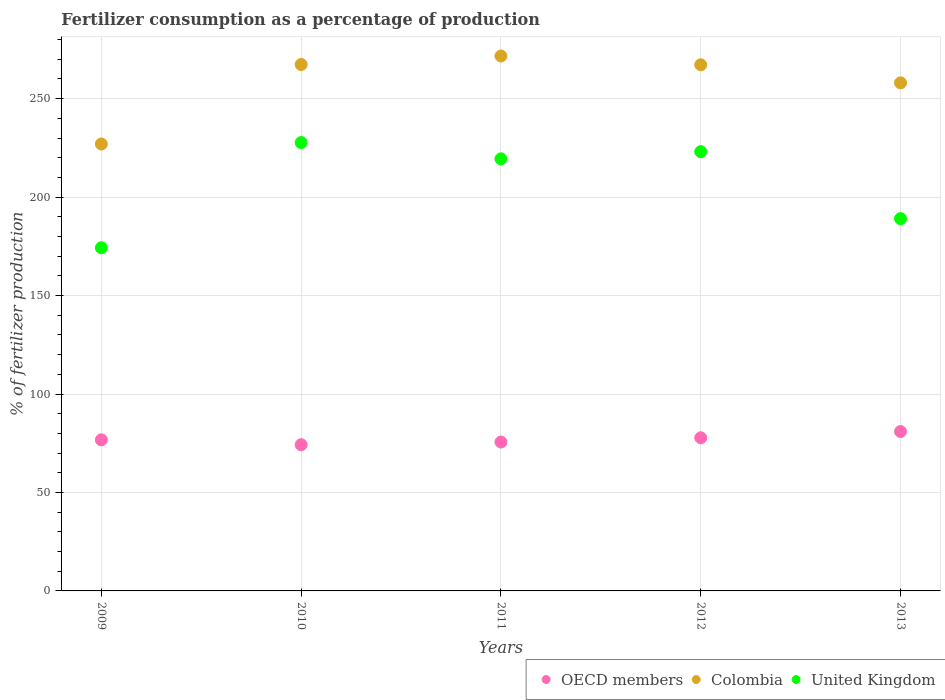How many different coloured dotlines are there?
Ensure brevity in your answer.  3. Is the number of dotlines equal to the number of legend labels?
Give a very brief answer. Yes. What is the percentage of fertilizers consumed in United Kingdom in 2011?
Your answer should be compact. 219.43. Across all years, what is the maximum percentage of fertilizers consumed in United Kingdom?
Your answer should be very brief. 227.69. Across all years, what is the minimum percentage of fertilizers consumed in United Kingdom?
Give a very brief answer. 174.26. In which year was the percentage of fertilizers consumed in United Kingdom maximum?
Provide a short and direct response. 2010. In which year was the percentage of fertilizers consumed in United Kingdom minimum?
Ensure brevity in your answer.  2009. What is the total percentage of fertilizers consumed in OECD members in the graph?
Provide a succinct answer. 385.32. What is the difference between the percentage of fertilizers consumed in OECD members in 2011 and that in 2013?
Keep it short and to the point. -5.33. What is the difference between the percentage of fertilizers consumed in Colombia in 2009 and the percentage of fertilizers consumed in OECD members in 2012?
Provide a succinct answer. 149.19. What is the average percentage of fertilizers consumed in United Kingdom per year?
Provide a succinct answer. 206.7. In the year 2011, what is the difference between the percentage of fertilizers consumed in United Kingdom and percentage of fertilizers consumed in Colombia?
Offer a very short reply. -52.23. In how many years, is the percentage of fertilizers consumed in OECD members greater than 250 %?
Make the answer very short. 0. What is the ratio of the percentage of fertilizers consumed in Colombia in 2010 to that in 2011?
Your answer should be very brief. 0.98. Is the percentage of fertilizers consumed in Colombia in 2010 less than that in 2013?
Provide a short and direct response. No. Is the difference between the percentage of fertilizers consumed in United Kingdom in 2009 and 2012 greater than the difference between the percentage of fertilizers consumed in Colombia in 2009 and 2012?
Your answer should be very brief. No. What is the difference between the highest and the second highest percentage of fertilizers consumed in United Kingdom?
Your answer should be compact. 4.62. What is the difference between the highest and the lowest percentage of fertilizers consumed in United Kingdom?
Your answer should be compact. 53.43. In how many years, is the percentage of fertilizers consumed in Colombia greater than the average percentage of fertilizers consumed in Colombia taken over all years?
Provide a succinct answer. 3. Is it the case that in every year, the sum of the percentage of fertilizers consumed in United Kingdom and percentage of fertilizers consumed in Colombia  is greater than the percentage of fertilizers consumed in OECD members?
Give a very brief answer. Yes. Is the percentage of fertilizers consumed in United Kingdom strictly greater than the percentage of fertilizers consumed in OECD members over the years?
Ensure brevity in your answer.  Yes. Is the percentage of fertilizers consumed in OECD members strictly less than the percentage of fertilizers consumed in Colombia over the years?
Make the answer very short. Yes. How many dotlines are there?
Make the answer very short. 3. How many years are there in the graph?
Give a very brief answer. 5. What is the difference between two consecutive major ticks on the Y-axis?
Give a very brief answer. 50. Does the graph contain grids?
Keep it short and to the point. Yes. Where does the legend appear in the graph?
Give a very brief answer. Bottom right. How many legend labels are there?
Provide a succinct answer. 3. How are the legend labels stacked?
Offer a very short reply. Horizontal. What is the title of the graph?
Offer a very short reply. Fertilizer consumption as a percentage of production. What is the label or title of the X-axis?
Give a very brief answer. Years. What is the label or title of the Y-axis?
Your answer should be compact. % of fertilizer production. What is the % of fertilizer production in OECD members in 2009?
Your answer should be compact. 76.72. What is the % of fertilizer production in Colombia in 2009?
Offer a terse response. 226.96. What is the % of fertilizer production in United Kingdom in 2009?
Offer a terse response. 174.26. What is the % of fertilizer production of OECD members in 2010?
Your response must be concise. 74.26. What is the % of fertilizer production of Colombia in 2010?
Your answer should be compact. 267.34. What is the % of fertilizer production of United Kingdom in 2010?
Make the answer very short. 227.69. What is the % of fertilizer production in OECD members in 2011?
Make the answer very short. 75.62. What is the % of fertilizer production in Colombia in 2011?
Offer a very short reply. 271.65. What is the % of fertilizer production of United Kingdom in 2011?
Keep it short and to the point. 219.43. What is the % of fertilizer production of OECD members in 2012?
Make the answer very short. 77.78. What is the % of fertilizer production in Colombia in 2012?
Keep it short and to the point. 267.2. What is the % of fertilizer production in United Kingdom in 2012?
Give a very brief answer. 223.08. What is the % of fertilizer production in OECD members in 2013?
Offer a terse response. 80.95. What is the % of fertilizer production of Colombia in 2013?
Offer a terse response. 258.03. What is the % of fertilizer production of United Kingdom in 2013?
Offer a very short reply. 189.06. Across all years, what is the maximum % of fertilizer production in OECD members?
Make the answer very short. 80.95. Across all years, what is the maximum % of fertilizer production in Colombia?
Give a very brief answer. 271.65. Across all years, what is the maximum % of fertilizer production of United Kingdom?
Your answer should be compact. 227.69. Across all years, what is the minimum % of fertilizer production in OECD members?
Provide a succinct answer. 74.26. Across all years, what is the minimum % of fertilizer production of Colombia?
Offer a very short reply. 226.96. Across all years, what is the minimum % of fertilizer production of United Kingdom?
Your answer should be compact. 174.26. What is the total % of fertilizer production in OECD members in the graph?
Your response must be concise. 385.32. What is the total % of fertilizer production in Colombia in the graph?
Provide a succinct answer. 1291.18. What is the total % of fertilizer production of United Kingdom in the graph?
Offer a terse response. 1033.51. What is the difference between the % of fertilizer production in OECD members in 2009 and that in 2010?
Offer a terse response. 2.45. What is the difference between the % of fertilizer production in Colombia in 2009 and that in 2010?
Give a very brief answer. -40.38. What is the difference between the % of fertilizer production of United Kingdom in 2009 and that in 2010?
Keep it short and to the point. -53.43. What is the difference between the % of fertilizer production of OECD members in 2009 and that in 2011?
Provide a succinct answer. 1.1. What is the difference between the % of fertilizer production of Colombia in 2009 and that in 2011?
Offer a very short reply. -44.69. What is the difference between the % of fertilizer production in United Kingdom in 2009 and that in 2011?
Provide a short and direct response. -45.16. What is the difference between the % of fertilizer production in OECD members in 2009 and that in 2012?
Offer a very short reply. -1.06. What is the difference between the % of fertilizer production of Colombia in 2009 and that in 2012?
Give a very brief answer. -40.24. What is the difference between the % of fertilizer production in United Kingdom in 2009 and that in 2012?
Make the answer very short. -48.81. What is the difference between the % of fertilizer production of OECD members in 2009 and that in 2013?
Your answer should be compact. -4.23. What is the difference between the % of fertilizer production of Colombia in 2009 and that in 2013?
Give a very brief answer. -31.06. What is the difference between the % of fertilizer production in United Kingdom in 2009 and that in 2013?
Your answer should be very brief. -14.79. What is the difference between the % of fertilizer production in OECD members in 2010 and that in 2011?
Your answer should be very brief. -1.35. What is the difference between the % of fertilizer production of Colombia in 2010 and that in 2011?
Provide a succinct answer. -4.31. What is the difference between the % of fertilizer production of United Kingdom in 2010 and that in 2011?
Provide a short and direct response. 8.27. What is the difference between the % of fertilizer production in OECD members in 2010 and that in 2012?
Ensure brevity in your answer.  -3.51. What is the difference between the % of fertilizer production in Colombia in 2010 and that in 2012?
Keep it short and to the point. 0.15. What is the difference between the % of fertilizer production in United Kingdom in 2010 and that in 2012?
Your response must be concise. 4.62. What is the difference between the % of fertilizer production of OECD members in 2010 and that in 2013?
Provide a short and direct response. -6.68. What is the difference between the % of fertilizer production of Colombia in 2010 and that in 2013?
Your answer should be compact. 9.32. What is the difference between the % of fertilizer production of United Kingdom in 2010 and that in 2013?
Your answer should be very brief. 38.64. What is the difference between the % of fertilizer production in OECD members in 2011 and that in 2012?
Offer a terse response. -2.16. What is the difference between the % of fertilizer production of Colombia in 2011 and that in 2012?
Provide a succinct answer. 4.46. What is the difference between the % of fertilizer production of United Kingdom in 2011 and that in 2012?
Make the answer very short. -3.65. What is the difference between the % of fertilizer production in OECD members in 2011 and that in 2013?
Your answer should be compact. -5.33. What is the difference between the % of fertilizer production of Colombia in 2011 and that in 2013?
Your answer should be very brief. 13.63. What is the difference between the % of fertilizer production of United Kingdom in 2011 and that in 2013?
Make the answer very short. 30.37. What is the difference between the % of fertilizer production in OECD members in 2012 and that in 2013?
Your answer should be compact. -3.17. What is the difference between the % of fertilizer production of Colombia in 2012 and that in 2013?
Provide a succinct answer. 9.17. What is the difference between the % of fertilizer production in United Kingdom in 2012 and that in 2013?
Offer a terse response. 34.02. What is the difference between the % of fertilizer production in OECD members in 2009 and the % of fertilizer production in Colombia in 2010?
Your response must be concise. -190.63. What is the difference between the % of fertilizer production in OECD members in 2009 and the % of fertilizer production in United Kingdom in 2010?
Your response must be concise. -150.98. What is the difference between the % of fertilizer production in Colombia in 2009 and the % of fertilizer production in United Kingdom in 2010?
Your answer should be very brief. -0.73. What is the difference between the % of fertilizer production of OECD members in 2009 and the % of fertilizer production of Colombia in 2011?
Keep it short and to the point. -194.94. What is the difference between the % of fertilizer production in OECD members in 2009 and the % of fertilizer production in United Kingdom in 2011?
Your answer should be very brief. -142.71. What is the difference between the % of fertilizer production in Colombia in 2009 and the % of fertilizer production in United Kingdom in 2011?
Your response must be concise. 7.54. What is the difference between the % of fertilizer production of OECD members in 2009 and the % of fertilizer production of Colombia in 2012?
Keep it short and to the point. -190.48. What is the difference between the % of fertilizer production in OECD members in 2009 and the % of fertilizer production in United Kingdom in 2012?
Your answer should be compact. -146.36. What is the difference between the % of fertilizer production of Colombia in 2009 and the % of fertilizer production of United Kingdom in 2012?
Offer a very short reply. 3.89. What is the difference between the % of fertilizer production of OECD members in 2009 and the % of fertilizer production of Colombia in 2013?
Keep it short and to the point. -181.31. What is the difference between the % of fertilizer production of OECD members in 2009 and the % of fertilizer production of United Kingdom in 2013?
Your answer should be very brief. -112.34. What is the difference between the % of fertilizer production in Colombia in 2009 and the % of fertilizer production in United Kingdom in 2013?
Provide a succinct answer. 37.91. What is the difference between the % of fertilizer production of OECD members in 2010 and the % of fertilizer production of Colombia in 2011?
Give a very brief answer. -197.39. What is the difference between the % of fertilizer production in OECD members in 2010 and the % of fertilizer production in United Kingdom in 2011?
Offer a very short reply. -145.16. What is the difference between the % of fertilizer production in Colombia in 2010 and the % of fertilizer production in United Kingdom in 2011?
Provide a succinct answer. 47.92. What is the difference between the % of fertilizer production in OECD members in 2010 and the % of fertilizer production in Colombia in 2012?
Make the answer very short. -192.94. What is the difference between the % of fertilizer production of OECD members in 2010 and the % of fertilizer production of United Kingdom in 2012?
Keep it short and to the point. -148.81. What is the difference between the % of fertilizer production of Colombia in 2010 and the % of fertilizer production of United Kingdom in 2012?
Provide a succinct answer. 44.27. What is the difference between the % of fertilizer production of OECD members in 2010 and the % of fertilizer production of Colombia in 2013?
Your answer should be compact. -183.76. What is the difference between the % of fertilizer production in OECD members in 2010 and the % of fertilizer production in United Kingdom in 2013?
Your response must be concise. -114.79. What is the difference between the % of fertilizer production of Colombia in 2010 and the % of fertilizer production of United Kingdom in 2013?
Your response must be concise. 78.29. What is the difference between the % of fertilizer production in OECD members in 2011 and the % of fertilizer production in Colombia in 2012?
Offer a very short reply. -191.58. What is the difference between the % of fertilizer production of OECD members in 2011 and the % of fertilizer production of United Kingdom in 2012?
Offer a terse response. -147.46. What is the difference between the % of fertilizer production in Colombia in 2011 and the % of fertilizer production in United Kingdom in 2012?
Give a very brief answer. 48.58. What is the difference between the % of fertilizer production in OECD members in 2011 and the % of fertilizer production in Colombia in 2013?
Give a very brief answer. -182.41. What is the difference between the % of fertilizer production of OECD members in 2011 and the % of fertilizer production of United Kingdom in 2013?
Offer a very short reply. -113.44. What is the difference between the % of fertilizer production in Colombia in 2011 and the % of fertilizer production in United Kingdom in 2013?
Ensure brevity in your answer.  82.6. What is the difference between the % of fertilizer production in OECD members in 2012 and the % of fertilizer production in Colombia in 2013?
Make the answer very short. -180.25. What is the difference between the % of fertilizer production in OECD members in 2012 and the % of fertilizer production in United Kingdom in 2013?
Provide a succinct answer. -111.28. What is the difference between the % of fertilizer production in Colombia in 2012 and the % of fertilizer production in United Kingdom in 2013?
Offer a terse response. 78.14. What is the average % of fertilizer production of OECD members per year?
Make the answer very short. 77.06. What is the average % of fertilizer production in Colombia per year?
Keep it short and to the point. 258.24. What is the average % of fertilizer production in United Kingdom per year?
Keep it short and to the point. 206.7. In the year 2009, what is the difference between the % of fertilizer production in OECD members and % of fertilizer production in Colombia?
Keep it short and to the point. -150.25. In the year 2009, what is the difference between the % of fertilizer production of OECD members and % of fertilizer production of United Kingdom?
Ensure brevity in your answer.  -97.55. In the year 2009, what is the difference between the % of fertilizer production in Colombia and % of fertilizer production in United Kingdom?
Your response must be concise. 52.7. In the year 2010, what is the difference between the % of fertilizer production in OECD members and % of fertilizer production in Colombia?
Provide a succinct answer. -193.08. In the year 2010, what is the difference between the % of fertilizer production of OECD members and % of fertilizer production of United Kingdom?
Offer a terse response. -153.43. In the year 2010, what is the difference between the % of fertilizer production of Colombia and % of fertilizer production of United Kingdom?
Make the answer very short. 39.65. In the year 2011, what is the difference between the % of fertilizer production in OECD members and % of fertilizer production in Colombia?
Ensure brevity in your answer.  -196.04. In the year 2011, what is the difference between the % of fertilizer production in OECD members and % of fertilizer production in United Kingdom?
Offer a very short reply. -143.81. In the year 2011, what is the difference between the % of fertilizer production in Colombia and % of fertilizer production in United Kingdom?
Provide a succinct answer. 52.23. In the year 2012, what is the difference between the % of fertilizer production in OECD members and % of fertilizer production in Colombia?
Provide a succinct answer. -189.42. In the year 2012, what is the difference between the % of fertilizer production in OECD members and % of fertilizer production in United Kingdom?
Your response must be concise. -145.3. In the year 2012, what is the difference between the % of fertilizer production in Colombia and % of fertilizer production in United Kingdom?
Give a very brief answer. 44.12. In the year 2013, what is the difference between the % of fertilizer production in OECD members and % of fertilizer production in Colombia?
Give a very brief answer. -177.08. In the year 2013, what is the difference between the % of fertilizer production in OECD members and % of fertilizer production in United Kingdom?
Provide a succinct answer. -108.11. In the year 2013, what is the difference between the % of fertilizer production of Colombia and % of fertilizer production of United Kingdom?
Keep it short and to the point. 68.97. What is the ratio of the % of fertilizer production in OECD members in 2009 to that in 2010?
Ensure brevity in your answer.  1.03. What is the ratio of the % of fertilizer production of Colombia in 2009 to that in 2010?
Give a very brief answer. 0.85. What is the ratio of the % of fertilizer production of United Kingdom in 2009 to that in 2010?
Keep it short and to the point. 0.77. What is the ratio of the % of fertilizer production in OECD members in 2009 to that in 2011?
Ensure brevity in your answer.  1.01. What is the ratio of the % of fertilizer production in Colombia in 2009 to that in 2011?
Your answer should be very brief. 0.84. What is the ratio of the % of fertilizer production of United Kingdom in 2009 to that in 2011?
Give a very brief answer. 0.79. What is the ratio of the % of fertilizer production in OECD members in 2009 to that in 2012?
Make the answer very short. 0.99. What is the ratio of the % of fertilizer production of Colombia in 2009 to that in 2012?
Offer a terse response. 0.85. What is the ratio of the % of fertilizer production in United Kingdom in 2009 to that in 2012?
Offer a very short reply. 0.78. What is the ratio of the % of fertilizer production of OECD members in 2009 to that in 2013?
Provide a succinct answer. 0.95. What is the ratio of the % of fertilizer production of Colombia in 2009 to that in 2013?
Make the answer very short. 0.88. What is the ratio of the % of fertilizer production of United Kingdom in 2009 to that in 2013?
Your answer should be very brief. 0.92. What is the ratio of the % of fertilizer production in OECD members in 2010 to that in 2011?
Provide a succinct answer. 0.98. What is the ratio of the % of fertilizer production of Colombia in 2010 to that in 2011?
Provide a short and direct response. 0.98. What is the ratio of the % of fertilizer production in United Kingdom in 2010 to that in 2011?
Your answer should be very brief. 1.04. What is the ratio of the % of fertilizer production in OECD members in 2010 to that in 2012?
Give a very brief answer. 0.95. What is the ratio of the % of fertilizer production in United Kingdom in 2010 to that in 2012?
Provide a short and direct response. 1.02. What is the ratio of the % of fertilizer production of OECD members in 2010 to that in 2013?
Your response must be concise. 0.92. What is the ratio of the % of fertilizer production in Colombia in 2010 to that in 2013?
Give a very brief answer. 1.04. What is the ratio of the % of fertilizer production in United Kingdom in 2010 to that in 2013?
Offer a terse response. 1.2. What is the ratio of the % of fertilizer production of OECD members in 2011 to that in 2012?
Offer a very short reply. 0.97. What is the ratio of the % of fertilizer production of Colombia in 2011 to that in 2012?
Your answer should be compact. 1.02. What is the ratio of the % of fertilizer production of United Kingdom in 2011 to that in 2012?
Ensure brevity in your answer.  0.98. What is the ratio of the % of fertilizer production in OECD members in 2011 to that in 2013?
Make the answer very short. 0.93. What is the ratio of the % of fertilizer production of Colombia in 2011 to that in 2013?
Keep it short and to the point. 1.05. What is the ratio of the % of fertilizer production of United Kingdom in 2011 to that in 2013?
Make the answer very short. 1.16. What is the ratio of the % of fertilizer production of OECD members in 2012 to that in 2013?
Your response must be concise. 0.96. What is the ratio of the % of fertilizer production in Colombia in 2012 to that in 2013?
Provide a succinct answer. 1.04. What is the ratio of the % of fertilizer production of United Kingdom in 2012 to that in 2013?
Your response must be concise. 1.18. What is the difference between the highest and the second highest % of fertilizer production in OECD members?
Provide a short and direct response. 3.17. What is the difference between the highest and the second highest % of fertilizer production of Colombia?
Offer a terse response. 4.31. What is the difference between the highest and the second highest % of fertilizer production of United Kingdom?
Offer a very short reply. 4.62. What is the difference between the highest and the lowest % of fertilizer production in OECD members?
Your response must be concise. 6.68. What is the difference between the highest and the lowest % of fertilizer production of Colombia?
Provide a succinct answer. 44.69. What is the difference between the highest and the lowest % of fertilizer production in United Kingdom?
Keep it short and to the point. 53.43. 